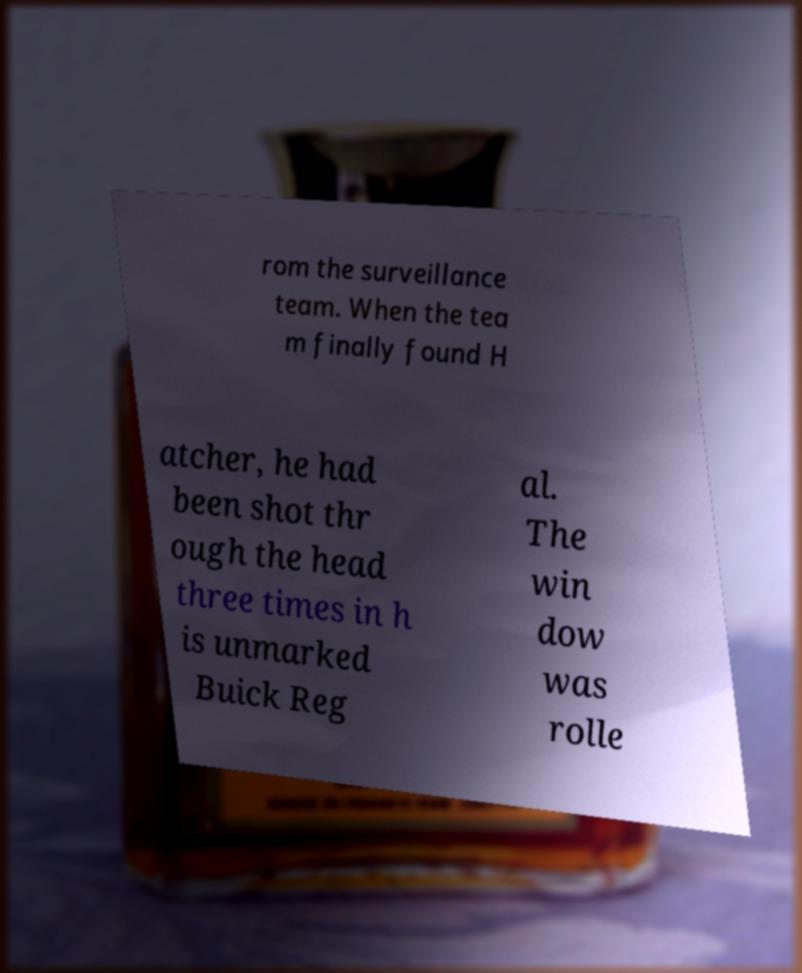For documentation purposes, I need the text within this image transcribed. Could you provide that? rom the surveillance team. When the tea m finally found H atcher, he had been shot thr ough the head three times in h is unmarked Buick Reg al. The win dow was rolle 